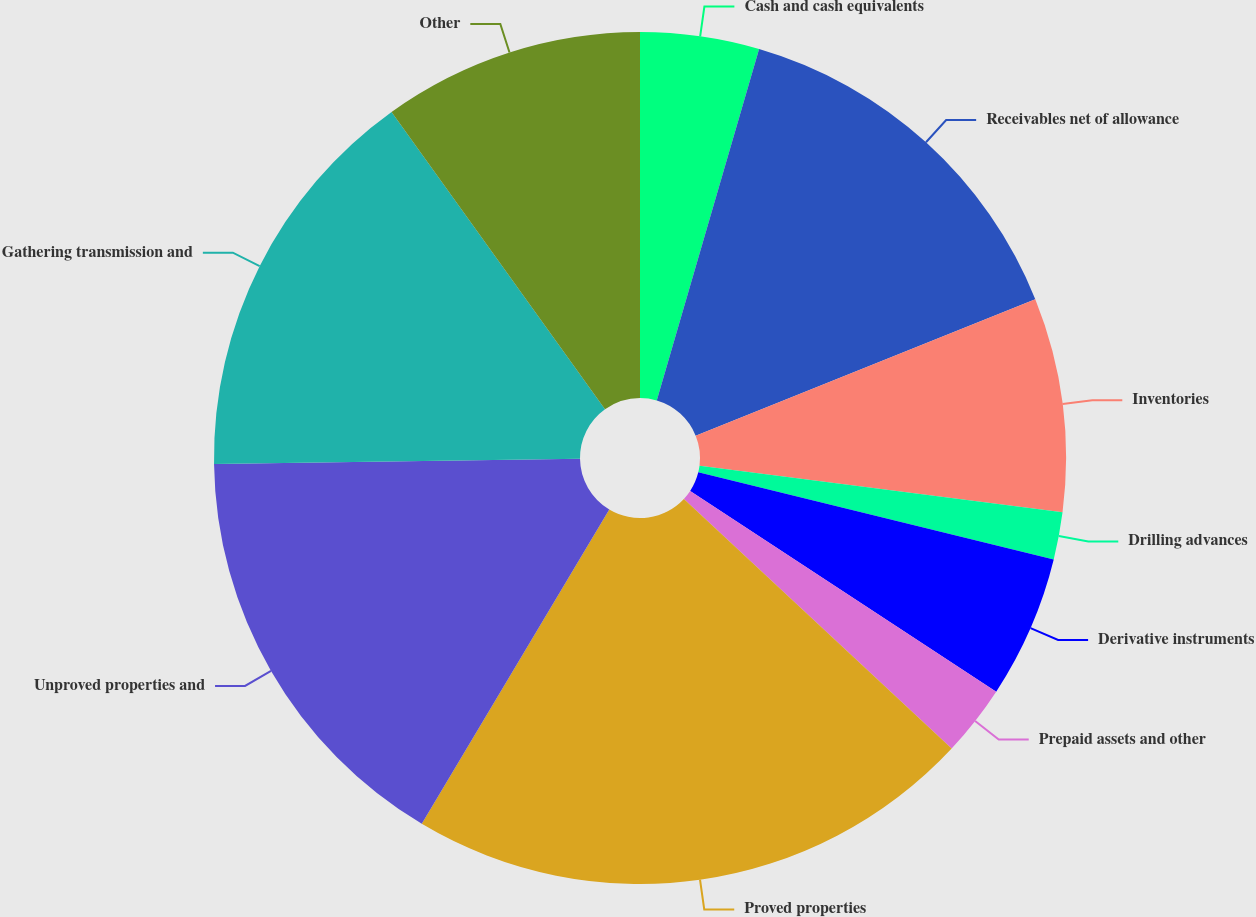Convert chart. <chart><loc_0><loc_0><loc_500><loc_500><pie_chart><fcel>Cash and cash equivalents<fcel>Receivables net of allowance<fcel>Inventories<fcel>Drilling advances<fcel>Derivative instruments<fcel>Prepaid assets and other<fcel>Proved properties<fcel>Unproved properties and<fcel>Gathering transmission and<fcel>Other<nl><fcel>4.51%<fcel>14.41%<fcel>8.11%<fcel>1.8%<fcel>5.41%<fcel>2.7%<fcel>21.62%<fcel>16.22%<fcel>15.31%<fcel>9.91%<nl></chart> 